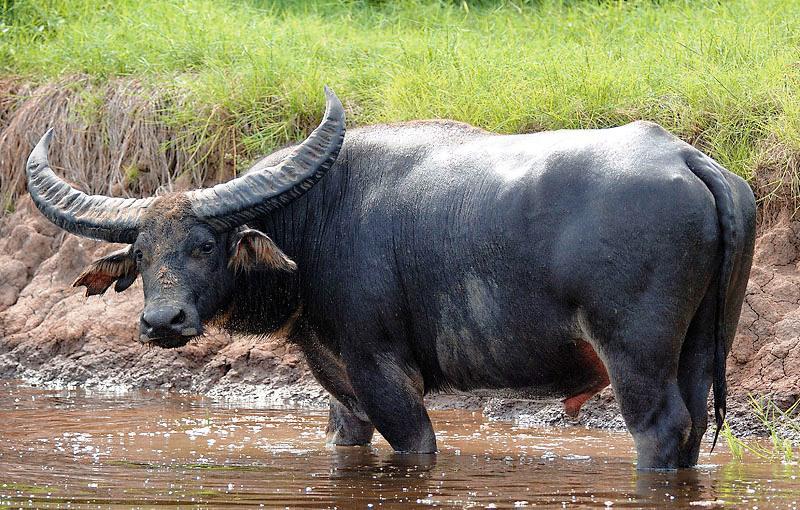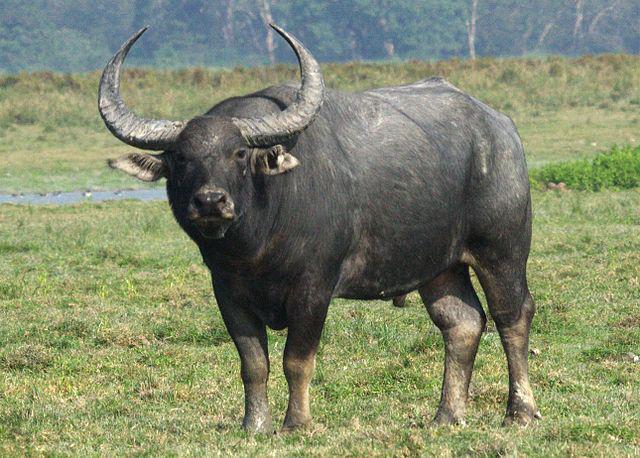The first image is the image on the left, the second image is the image on the right. Considering the images on both sides, is "There are two buffalos facing away from each other." valid? Answer yes or no. No. 